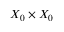<formula> <loc_0><loc_0><loc_500><loc_500>X _ { 0 } \times X _ { 0 }</formula> 